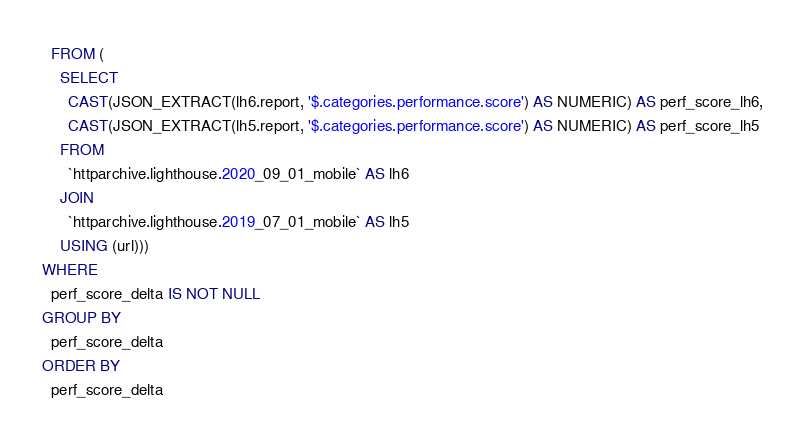Convert code to text. <code><loc_0><loc_0><loc_500><loc_500><_SQL_>  FROM (
    SELECT
      CAST(JSON_EXTRACT(lh6.report, '$.categories.performance.score') AS NUMERIC) AS perf_score_lh6,
      CAST(JSON_EXTRACT(lh5.report, '$.categories.performance.score') AS NUMERIC) AS perf_score_lh5
    FROM
      `httparchive.lighthouse.2020_09_01_mobile` AS lh6
    JOIN
      `httparchive.lighthouse.2019_07_01_mobile` AS lh5
    USING (url)))
WHERE
  perf_score_delta IS NOT NULL
GROUP BY
  perf_score_delta
ORDER BY
  perf_score_delta
</code> 